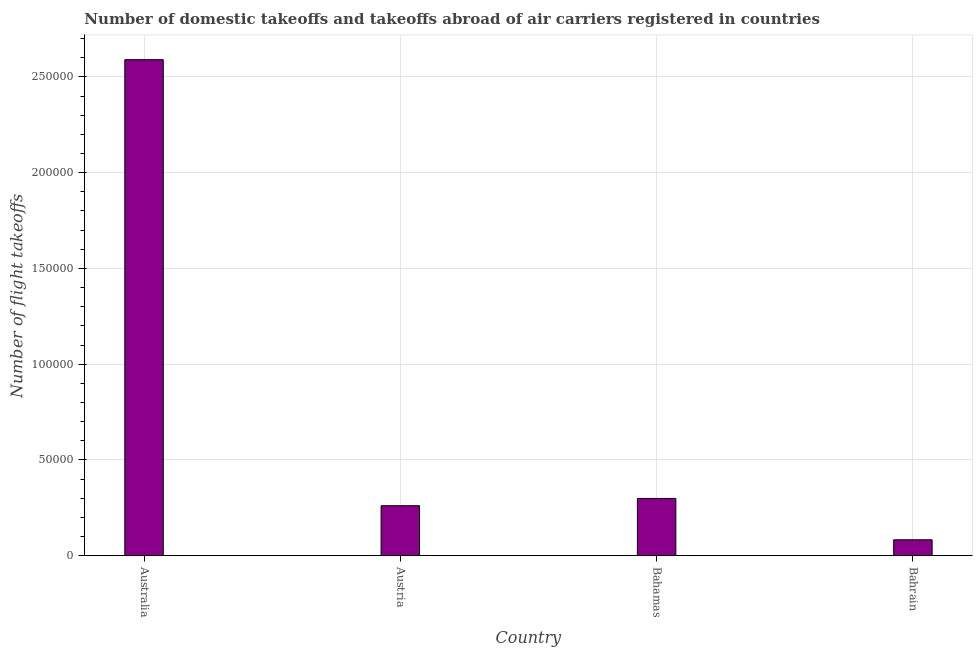Does the graph contain any zero values?
Provide a short and direct response. No. What is the title of the graph?
Your response must be concise. Number of domestic takeoffs and takeoffs abroad of air carriers registered in countries. What is the label or title of the X-axis?
Ensure brevity in your answer.  Country. What is the label or title of the Y-axis?
Offer a very short reply. Number of flight takeoffs. What is the number of flight takeoffs in Australia?
Offer a very short reply. 2.59e+05. Across all countries, what is the maximum number of flight takeoffs?
Ensure brevity in your answer.  2.59e+05. Across all countries, what is the minimum number of flight takeoffs?
Your answer should be very brief. 8300. In which country was the number of flight takeoffs minimum?
Provide a short and direct response. Bahrain. What is the sum of the number of flight takeoffs?
Provide a short and direct response. 3.23e+05. What is the difference between the number of flight takeoffs in Australia and Bahamas?
Keep it short and to the point. 2.29e+05. What is the average number of flight takeoffs per country?
Offer a very short reply. 8.08e+04. What is the median number of flight takeoffs?
Provide a succinct answer. 2.80e+04. In how many countries, is the number of flight takeoffs greater than 40000 ?
Your answer should be very brief. 1. What is the ratio of the number of flight takeoffs in Austria to that in Bahamas?
Your answer should be compact. 0.87. What is the difference between the highest and the second highest number of flight takeoffs?
Make the answer very short. 2.29e+05. What is the difference between the highest and the lowest number of flight takeoffs?
Offer a terse response. 2.51e+05. In how many countries, is the number of flight takeoffs greater than the average number of flight takeoffs taken over all countries?
Keep it short and to the point. 1. How many bars are there?
Offer a very short reply. 4. What is the Number of flight takeoffs of Australia?
Keep it short and to the point. 2.59e+05. What is the Number of flight takeoffs in Austria?
Offer a very short reply. 2.61e+04. What is the Number of flight takeoffs in Bahamas?
Give a very brief answer. 2.99e+04. What is the Number of flight takeoffs in Bahrain?
Offer a terse response. 8300. What is the difference between the Number of flight takeoffs in Australia and Austria?
Ensure brevity in your answer.  2.33e+05. What is the difference between the Number of flight takeoffs in Australia and Bahamas?
Give a very brief answer. 2.29e+05. What is the difference between the Number of flight takeoffs in Australia and Bahrain?
Offer a very short reply. 2.51e+05. What is the difference between the Number of flight takeoffs in Austria and Bahamas?
Offer a terse response. -3800. What is the difference between the Number of flight takeoffs in Austria and Bahrain?
Your answer should be very brief. 1.78e+04. What is the difference between the Number of flight takeoffs in Bahamas and Bahrain?
Your answer should be compact. 2.16e+04. What is the ratio of the Number of flight takeoffs in Australia to that in Austria?
Offer a terse response. 9.92. What is the ratio of the Number of flight takeoffs in Australia to that in Bahamas?
Ensure brevity in your answer.  8.66. What is the ratio of the Number of flight takeoffs in Australia to that in Bahrain?
Offer a very short reply. 31.2. What is the ratio of the Number of flight takeoffs in Austria to that in Bahamas?
Offer a terse response. 0.87. What is the ratio of the Number of flight takeoffs in Austria to that in Bahrain?
Ensure brevity in your answer.  3.15. What is the ratio of the Number of flight takeoffs in Bahamas to that in Bahrain?
Keep it short and to the point. 3.6. 